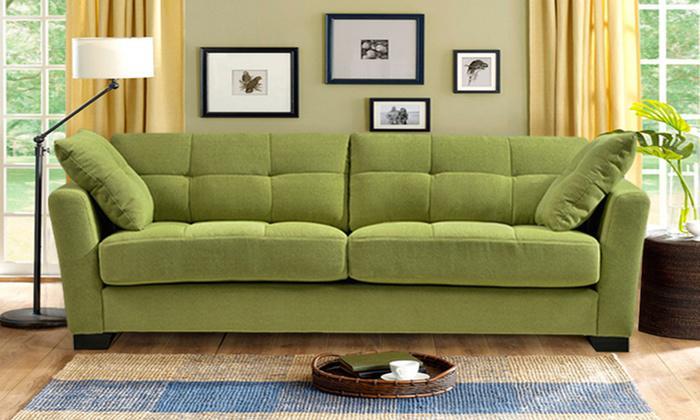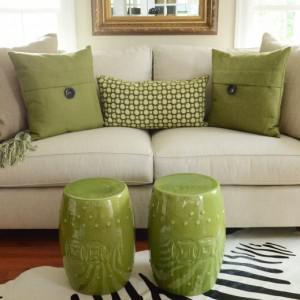The first image is the image on the left, the second image is the image on the right. Assess this claim about the two images: "The combined images include a solid green sofa, green cylindrical shape, green plant, and green printed pillows.". Correct or not? Answer yes or no. Yes. The first image is the image on the left, the second image is the image on the right. Analyze the images presented: Is the assertion "Both images show a vase of flowers sitting on top of a coffee table." valid? Answer yes or no. No. 